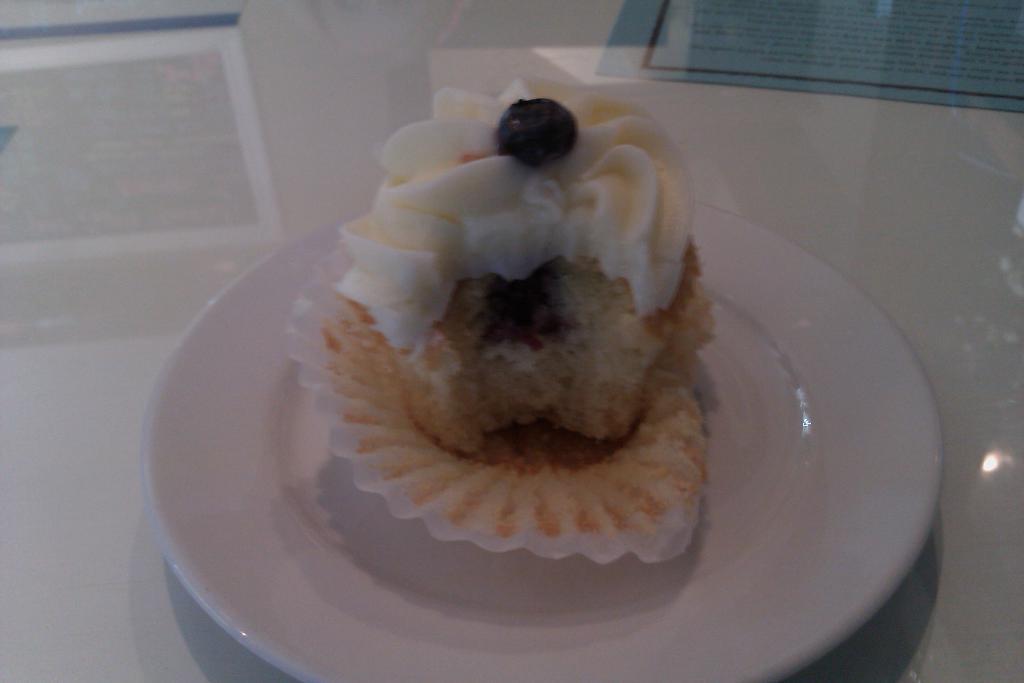Can you describe this image briefly? In this image I can see a food on the white color plate. The plate is on the white surface and Back I can see the blue paper. 